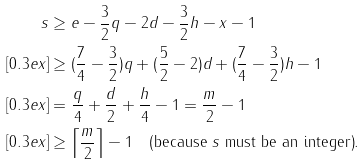Convert formula to latex. <formula><loc_0><loc_0><loc_500><loc_500>s & \geq e - { \frac { 3 } { 2 } } q - 2 d - { \frac { 3 } { 2 } } h - x - 1 \\ [ 0 . 3 e x ] & \geq ( { \frac { 7 } { 4 } } - { \frac { 3 } { 2 } } ) q + ( { \frac { 5 } { 2 } } - 2 ) d + ( { \frac { 7 } { 4 } } - { \frac { 3 } { 2 } } ) h - 1 \\ [ 0 . 3 e x ] & = { \frac { q } { 4 } } + { \frac { d } { 2 } } + { \frac { h } { 4 } } - 1 = { \frac { m } { 2 } } - 1 \\ [ 0 . 3 e x ] & \geq \left \lceil { \frac { m } { 2 } } \right \rceil - 1 \quad \text {(because $s$   must be an integer)} .</formula> 